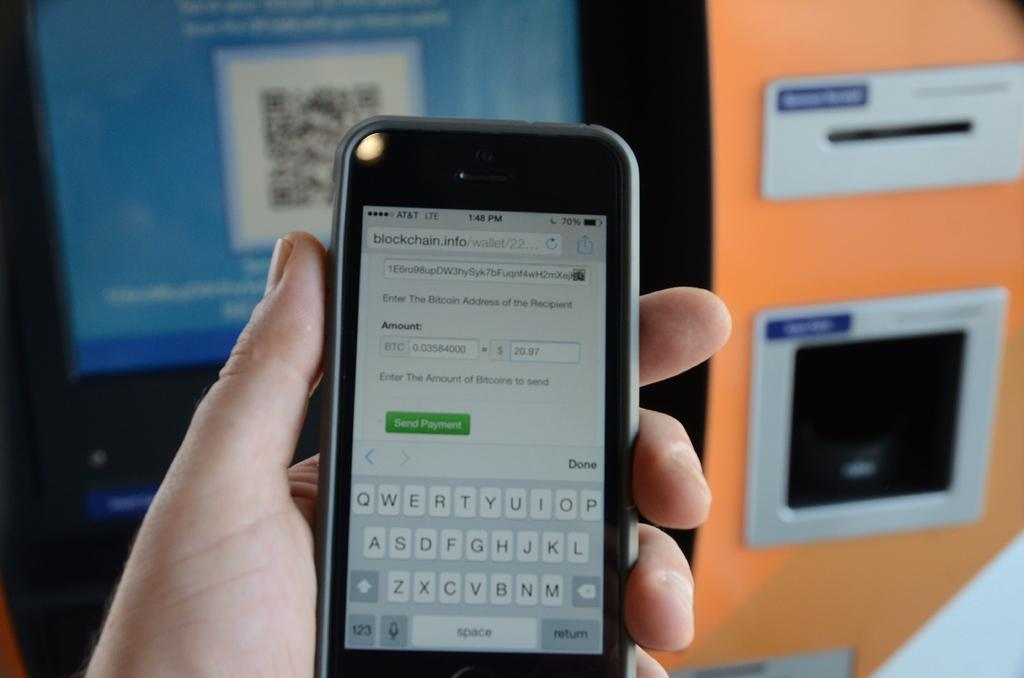<image>
Provide a brief description of the given image. A hand is holding a cellphone with service by AT&T. 